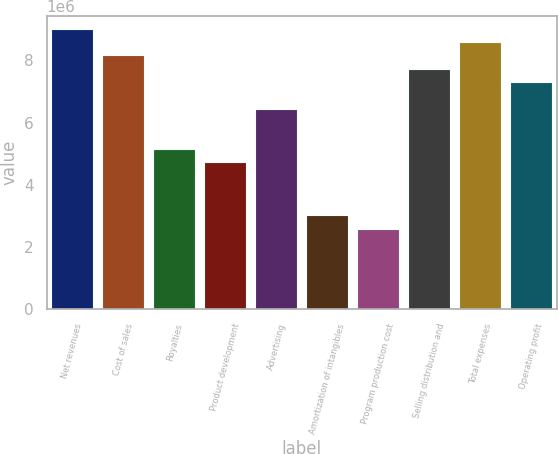Convert chart to OTSL. <chart><loc_0><loc_0><loc_500><loc_500><bar_chart><fcel>Net revenues<fcel>Cost of sales<fcel>Royalties<fcel>Product development<fcel>Advertising<fcel>Amortization of intangibles<fcel>Program production cost<fcel>Selling distribution and<fcel>Total expenses<fcel>Operating profit<nl><fcel>8.98213e+06<fcel>8.12669e+06<fcel>5.13265e+06<fcel>4.70493e+06<fcel>6.41581e+06<fcel>2.99405e+06<fcel>2.56632e+06<fcel>7.69897e+06<fcel>8.55441e+06<fcel>7.27125e+06<nl></chart> 